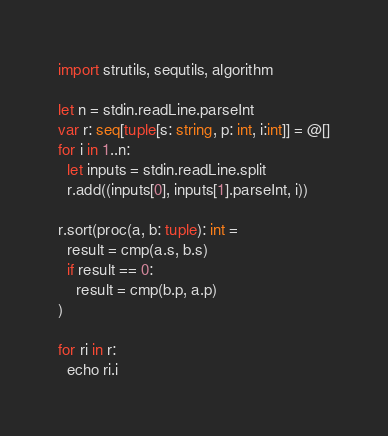<code> <loc_0><loc_0><loc_500><loc_500><_Nim_>import strutils, sequtils, algorithm

let n = stdin.readLine.parseInt
var r: seq[tuple[s: string, p: int, i:int]] = @[]
for i in 1..n:
  let inputs = stdin.readLine.split
  r.add((inputs[0], inputs[1].parseInt, i))

r.sort(proc(a, b: tuple): int =
  result = cmp(a.s, b.s)
  if result == 0:
    result = cmp(b.p, a.p)
)

for ri in r:
  echo ri.i</code> 